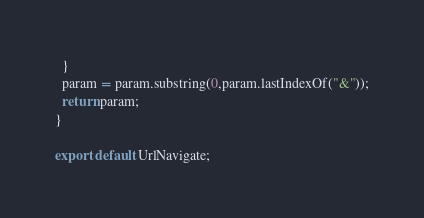<code> <loc_0><loc_0><loc_500><loc_500><_JavaScript_>  }
  param = param.substring(0,param.lastIndexOf("&"));
  return param;
}

export default UrlNavigate;
</code> 